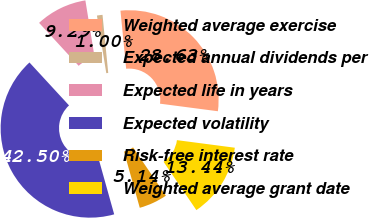<chart> <loc_0><loc_0><loc_500><loc_500><pie_chart><fcel>Weighted average exercise<fcel>Expected annual dividends per<fcel>Expected life in years<fcel>Expected volatility<fcel>Risk-free interest rate<fcel>Weighted average grant date<nl><fcel>28.63%<fcel>1.0%<fcel>9.29%<fcel>42.5%<fcel>5.14%<fcel>13.44%<nl></chart> 